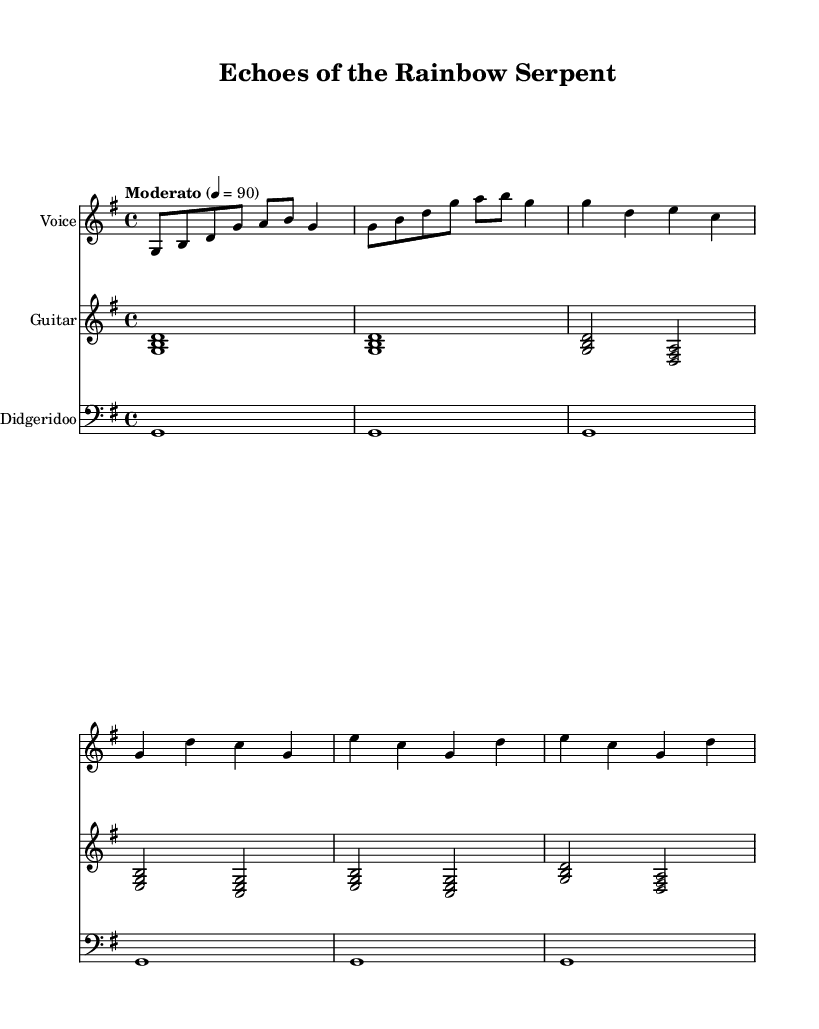What is the key signature of this music? The key signature is G major, which has one sharp (F#). This can be identified at the beginning of the music sheet, where the key signature is marked.
Answer: G major What is the time signature of the piece? The time signature is 4/4, indicated by the fraction at the beginning of the score. This means there are four beats in each measure, and a quarter note receives one beat.
Answer: 4/4 What is the tempo marking of the piece? The tempo marking states "Moderato" with a metronome marking of 90 beats per minute. This information is present in the tempo indication at the start of the music.
Answer: Moderato 90 How many measures are in the verse section? The verse consists of two measures, as indicated in the notation. Each line typically has four beats, and two measures are written for the verse lyrics.
Answer: 2 What instruments are used in this piece? The instruments indicated in the score are voice, guitar, and didgeridoo, shown in separate staves labeled for each instrument.
Answer: Voice, guitar, didgeridoo What is the main theme of the chorus lyrics? The chorus expresses the theme of dreams and the Rainbow Serpent's story, as indicated by the words "Echoes of the Dreaming, ancient and true" found in the chorus lyrics.
Answer: Dreaming, Rainbow Serpent Which instrument plays a continuous drone throughout the piece? The didgeridoo is specified to play a continuous drone, indicated by the notation marking for the didgeridoo staff, which is consistent across measures.
Answer: Didgeridoo 